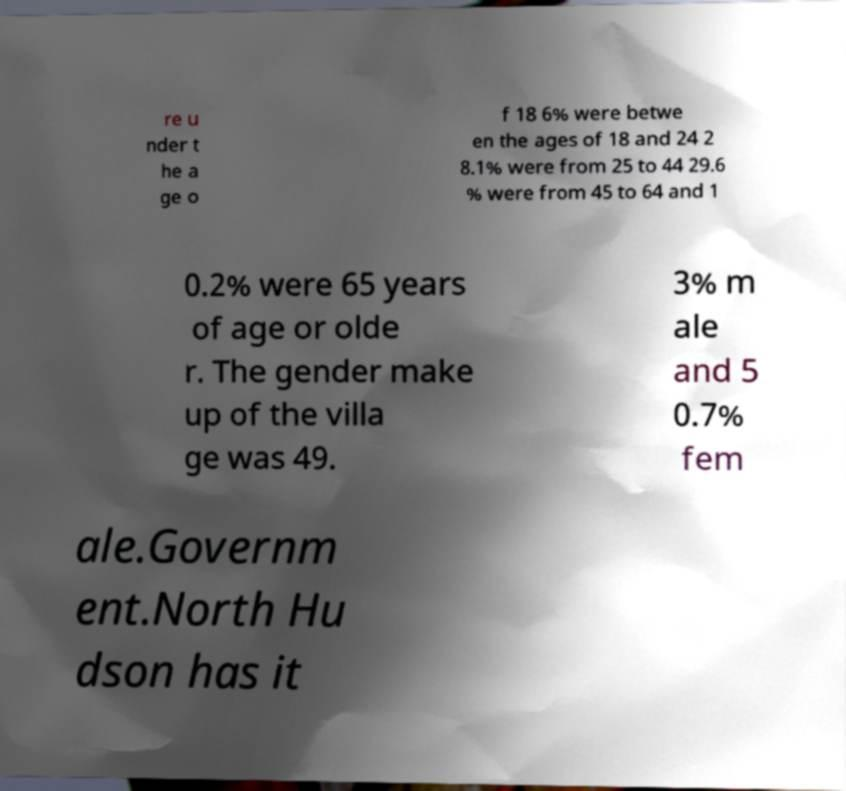For documentation purposes, I need the text within this image transcribed. Could you provide that? re u nder t he a ge o f 18 6% were betwe en the ages of 18 and 24 2 8.1% were from 25 to 44 29.6 % were from 45 to 64 and 1 0.2% were 65 years of age or olde r. The gender make up of the villa ge was 49. 3% m ale and 5 0.7% fem ale.Governm ent.North Hu dson has it 